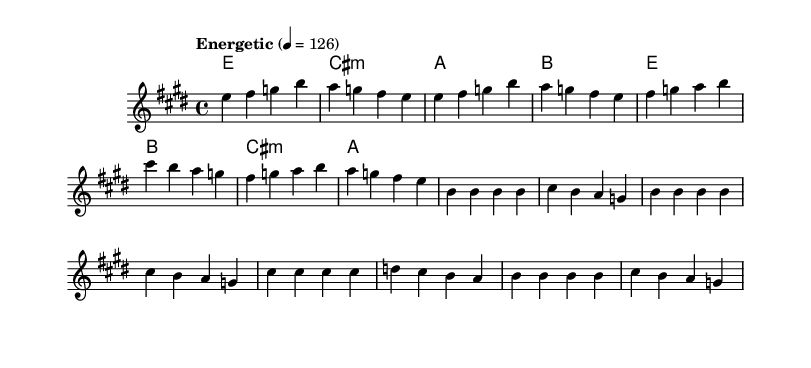What is the key signature of this music? The key signature is E major, which has four sharps (F#, C#, G#, D#). This is indicated at the beginning of the score after the clef.
Answer: E major What is the time signature of the piece? The time signature is 4/4 as noted at the beginning of the score. This indicates that there are four beats in a measure and the quarter note gets one beat.
Answer: 4/4 What is the tempo marking provided in the sheet music? The tempo marking is "Energetic" with a metronome marking of 126 beats per minute, specified at the start of the score.
Answer: Energetic How many measures are in the verse section? The verse section contains 8 measures, which can be counted by looking at the number of vertical lines in that section.
Answer: 8 What is the chord progression for the chorus? The chord progression for the chorus consists of E, B, C# minor, and A, which can be found in the chord mode lines for the chorus section.
Answer: E, B, C# minor, A What themes are expressed in the lyrics of the verse? The themes expressed in the verse lyrics are skepticism towards narratives and a call for independent inquiry and enlightenment, as outlined in the text of the verse.
Answer: Skepticism and inquiry What is the primary message encouraged by the chorus? The primary message of the chorus is to encourage questioning and independent thinking concerning belief and faith, which is articulated in the wording of the chorus lyrics.
Answer: Question everything 